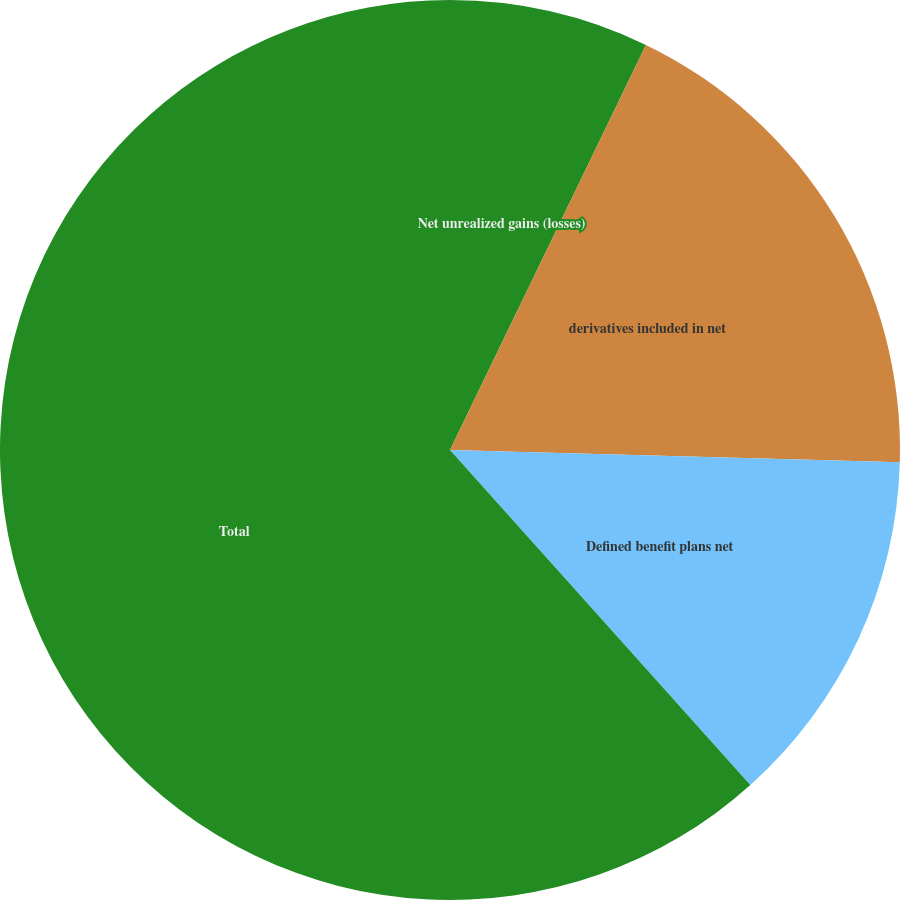<chart> <loc_0><loc_0><loc_500><loc_500><pie_chart><fcel>Net unrealized gains (losses)<fcel>derivatives included in net<fcel>Defined benefit plans net<fcel>Total<nl><fcel>7.17%<fcel>18.26%<fcel>12.94%<fcel>61.63%<nl></chart> 